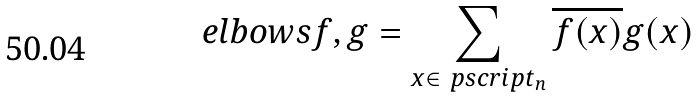<formula> <loc_0><loc_0><loc_500><loc_500>\ e l b o w s { f , g } = \sum _ { x \in \ p s c r i p t _ { n } } \overline { f ( x ) } g ( x )</formula> 